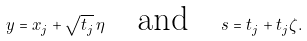Convert formula to latex. <formula><loc_0><loc_0><loc_500><loc_500>y = x _ { j } + \sqrt { t _ { j } } \, \eta \quad \text {and} \quad s = t _ { j } + t _ { j } \zeta .</formula> 